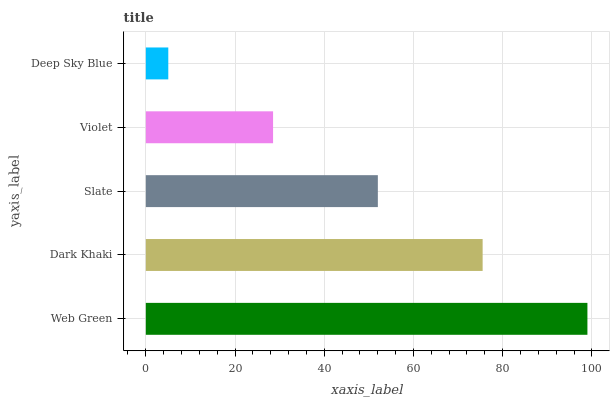Is Deep Sky Blue the minimum?
Answer yes or no. Yes. Is Web Green the maximum?
Answer yes or no. Yes. Is Dark Khaki the minimum?
Answer yes or no. No. Is Dark Khaki the maximum?
Answer yes or no. No. Is Web Green greater than Dark Khaki?
Answer yes or no. Yes. Is Dark Khaki less than Web Green?
Answer yes or no. Yes. Is Dark Khaki greater than Web Green?
Answer yes or no. No. Is Web Green less than Dark Khaki?
Answer yes or no. No. Is Slate the high median?
Answer yes or no. Yes. Is Slate the low median?
Answer yes or no. Yes. Is Deep Sky Blue the high median?
Answer yes or no. No. Is Web Green the low median?
Answer yes or no. No. 